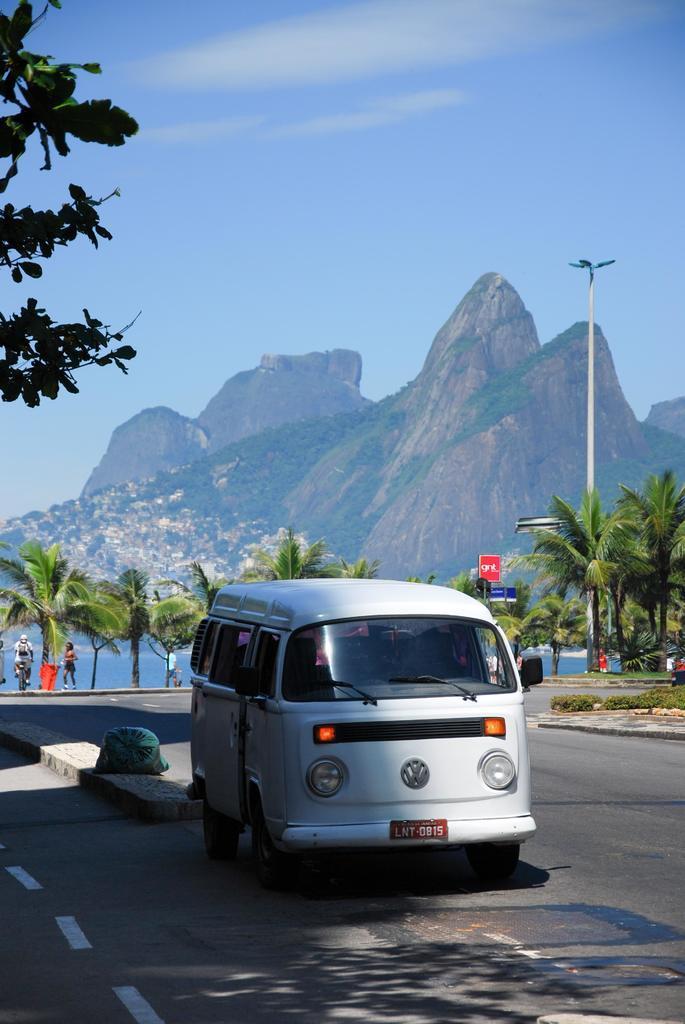How would you summarize this image in a sentence or two? We can see vehicle on the road. Background we can see trees,people,pole,water,hills and sky. 